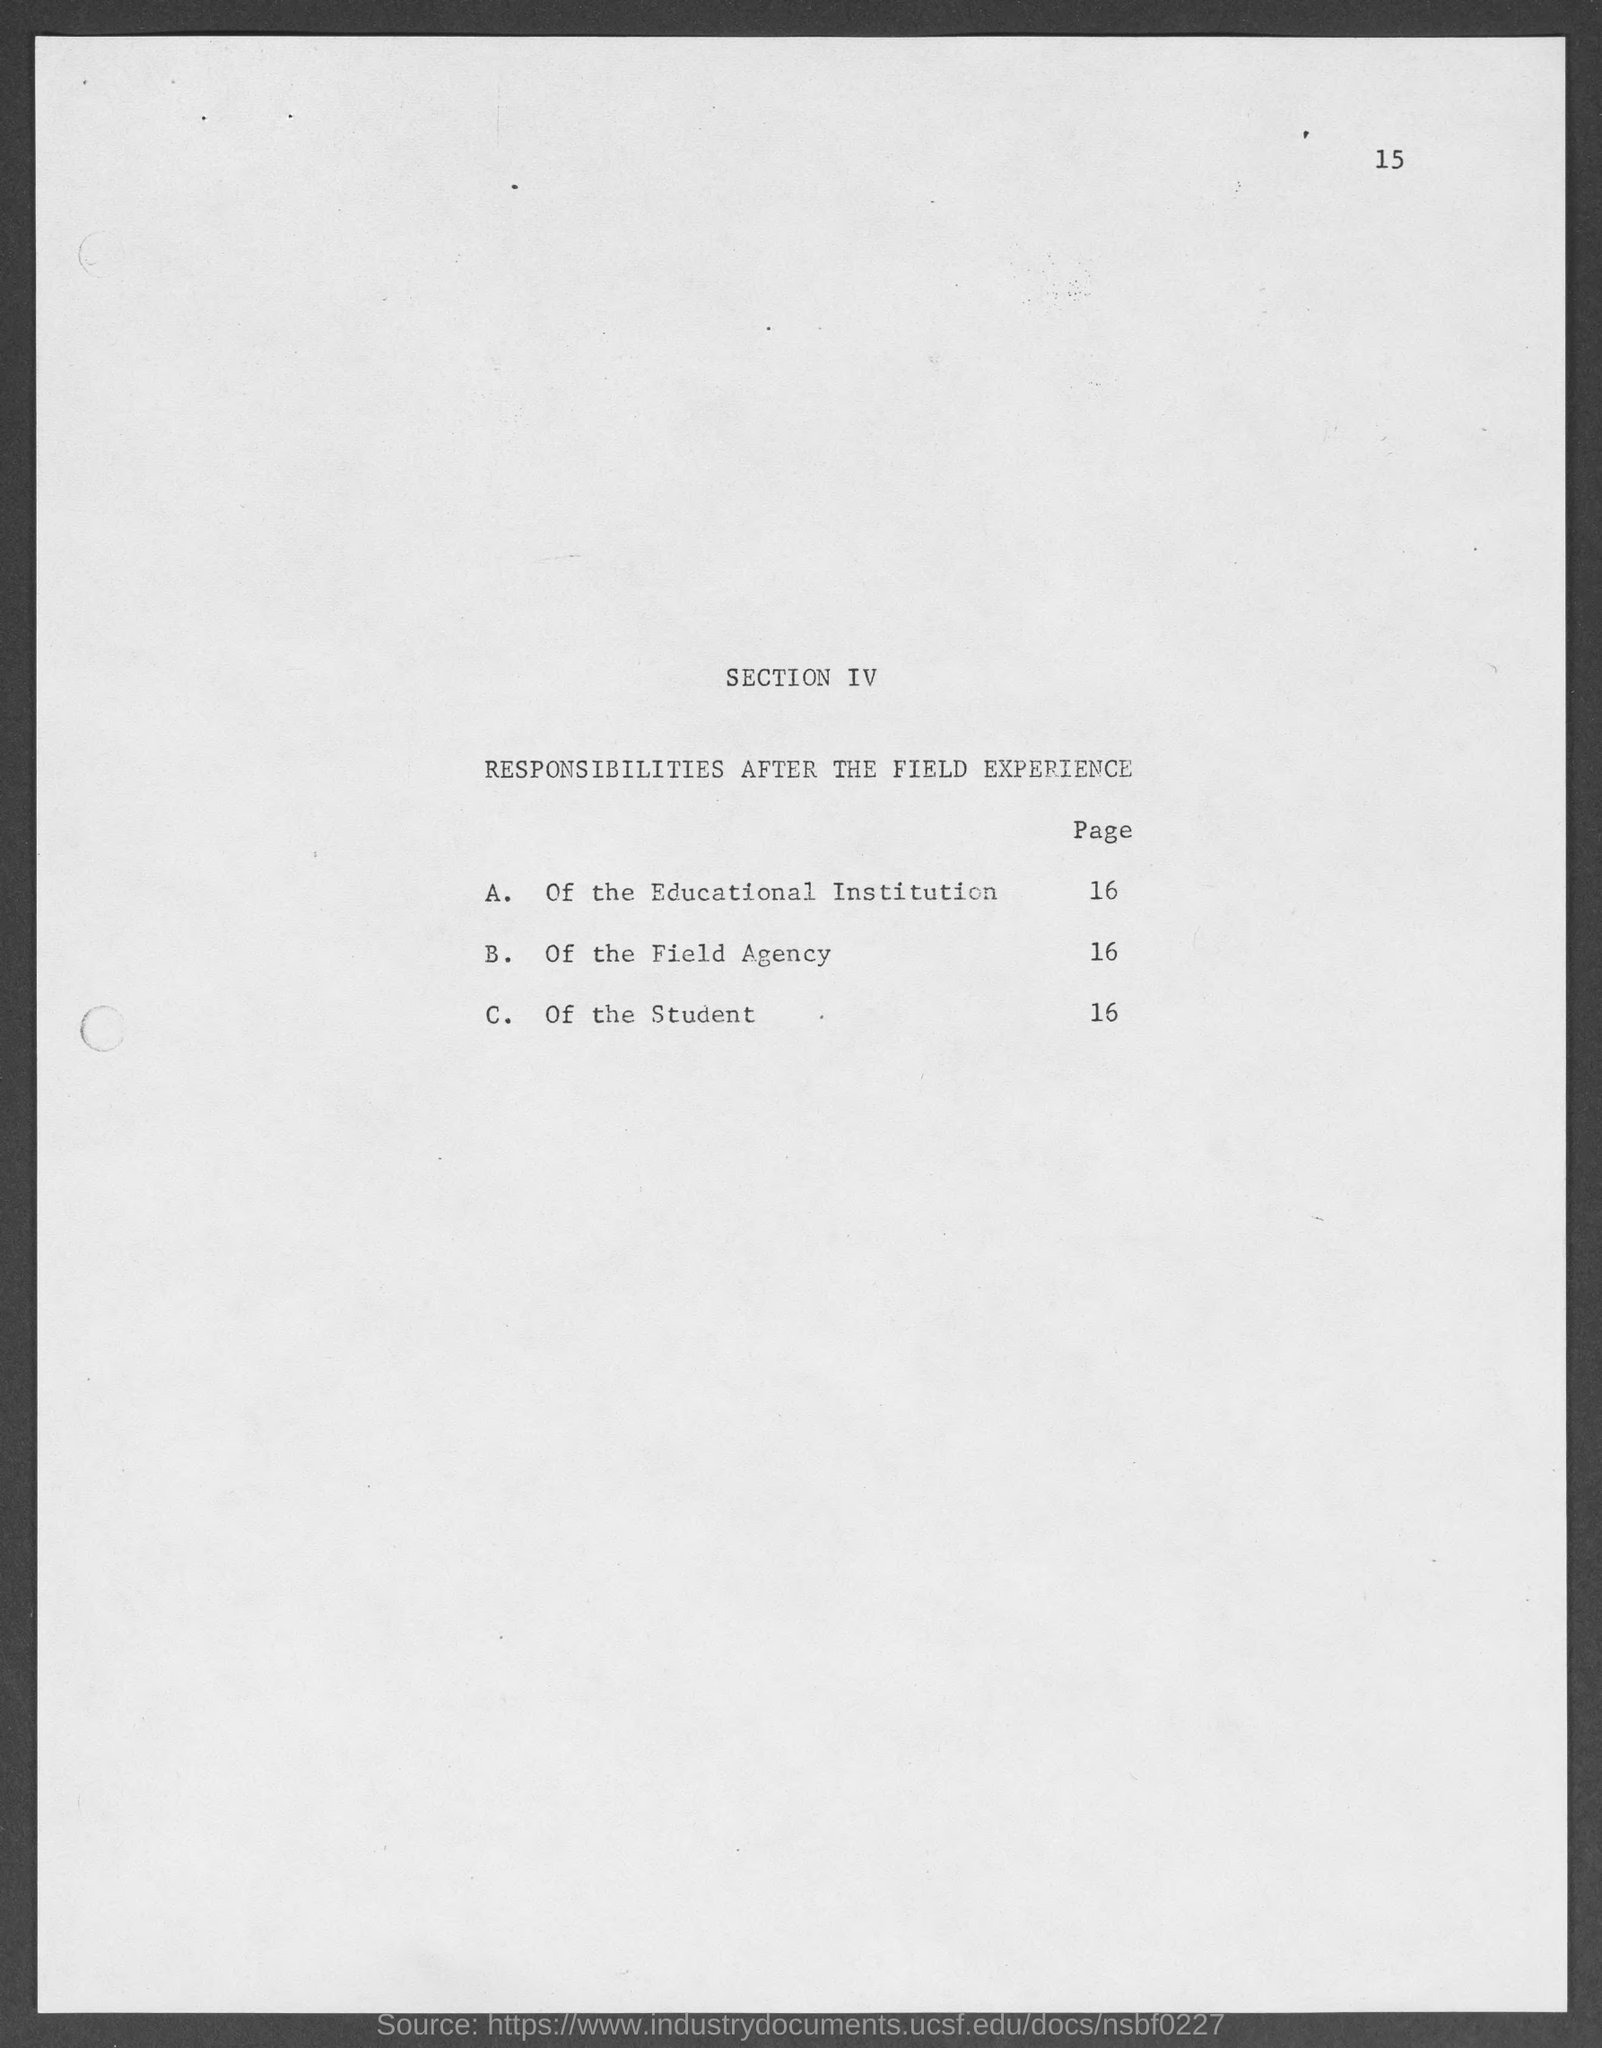Highlight a few significant elements in this photo. Section IV of the document deals with responsibilities after the field experience. 